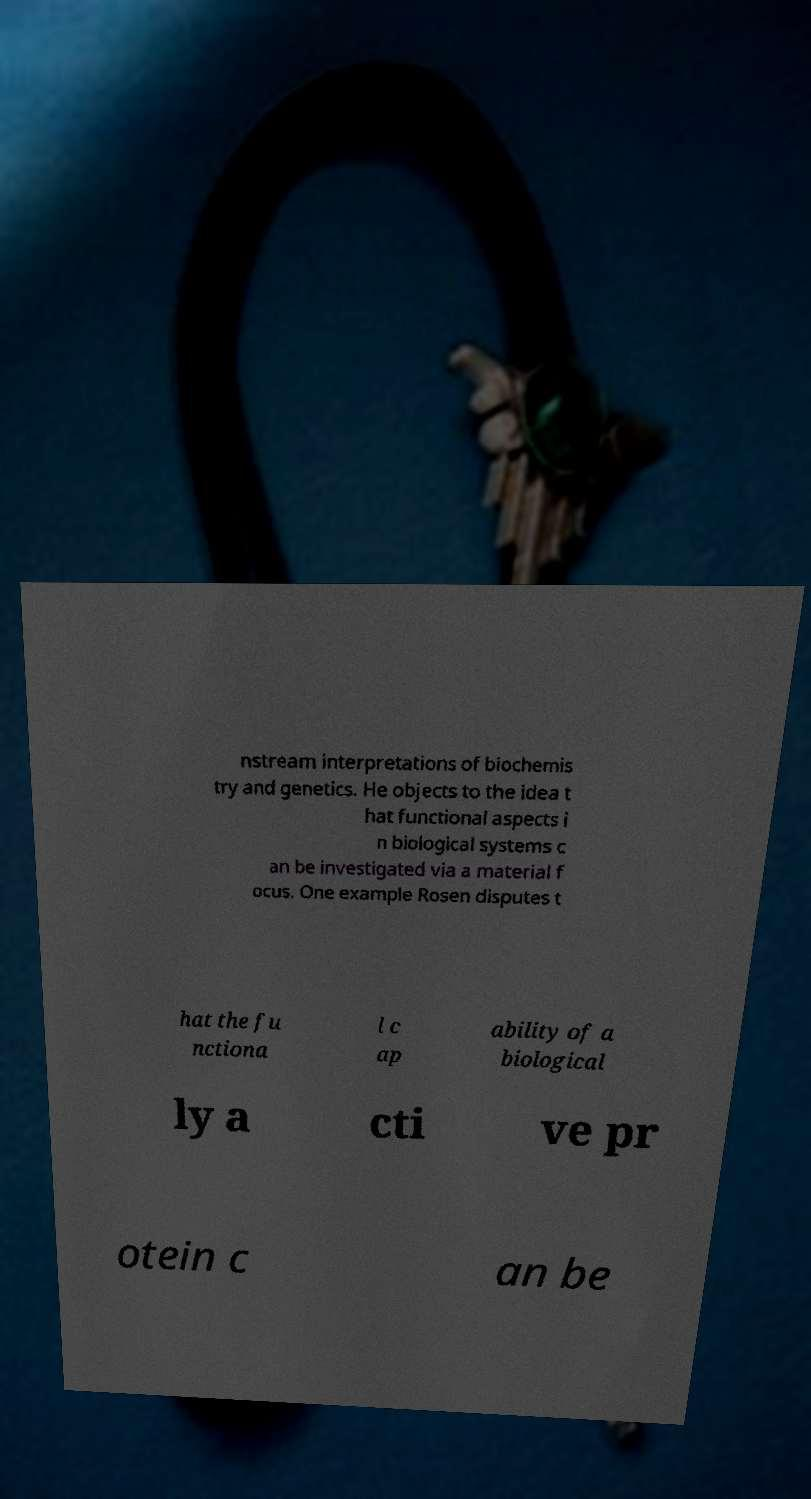For documentation purposes, I need the text within this image transcribed. Could you provide that? nstream interpretations of biochemis try and genetics. He objects to the idea t hat functional aspects i n biological systems c an be investigated via a material f ocus. One example Rosen disputes t hat the fu nctiona l c ap ability of a biological ly a cti ve pr otein c an be 